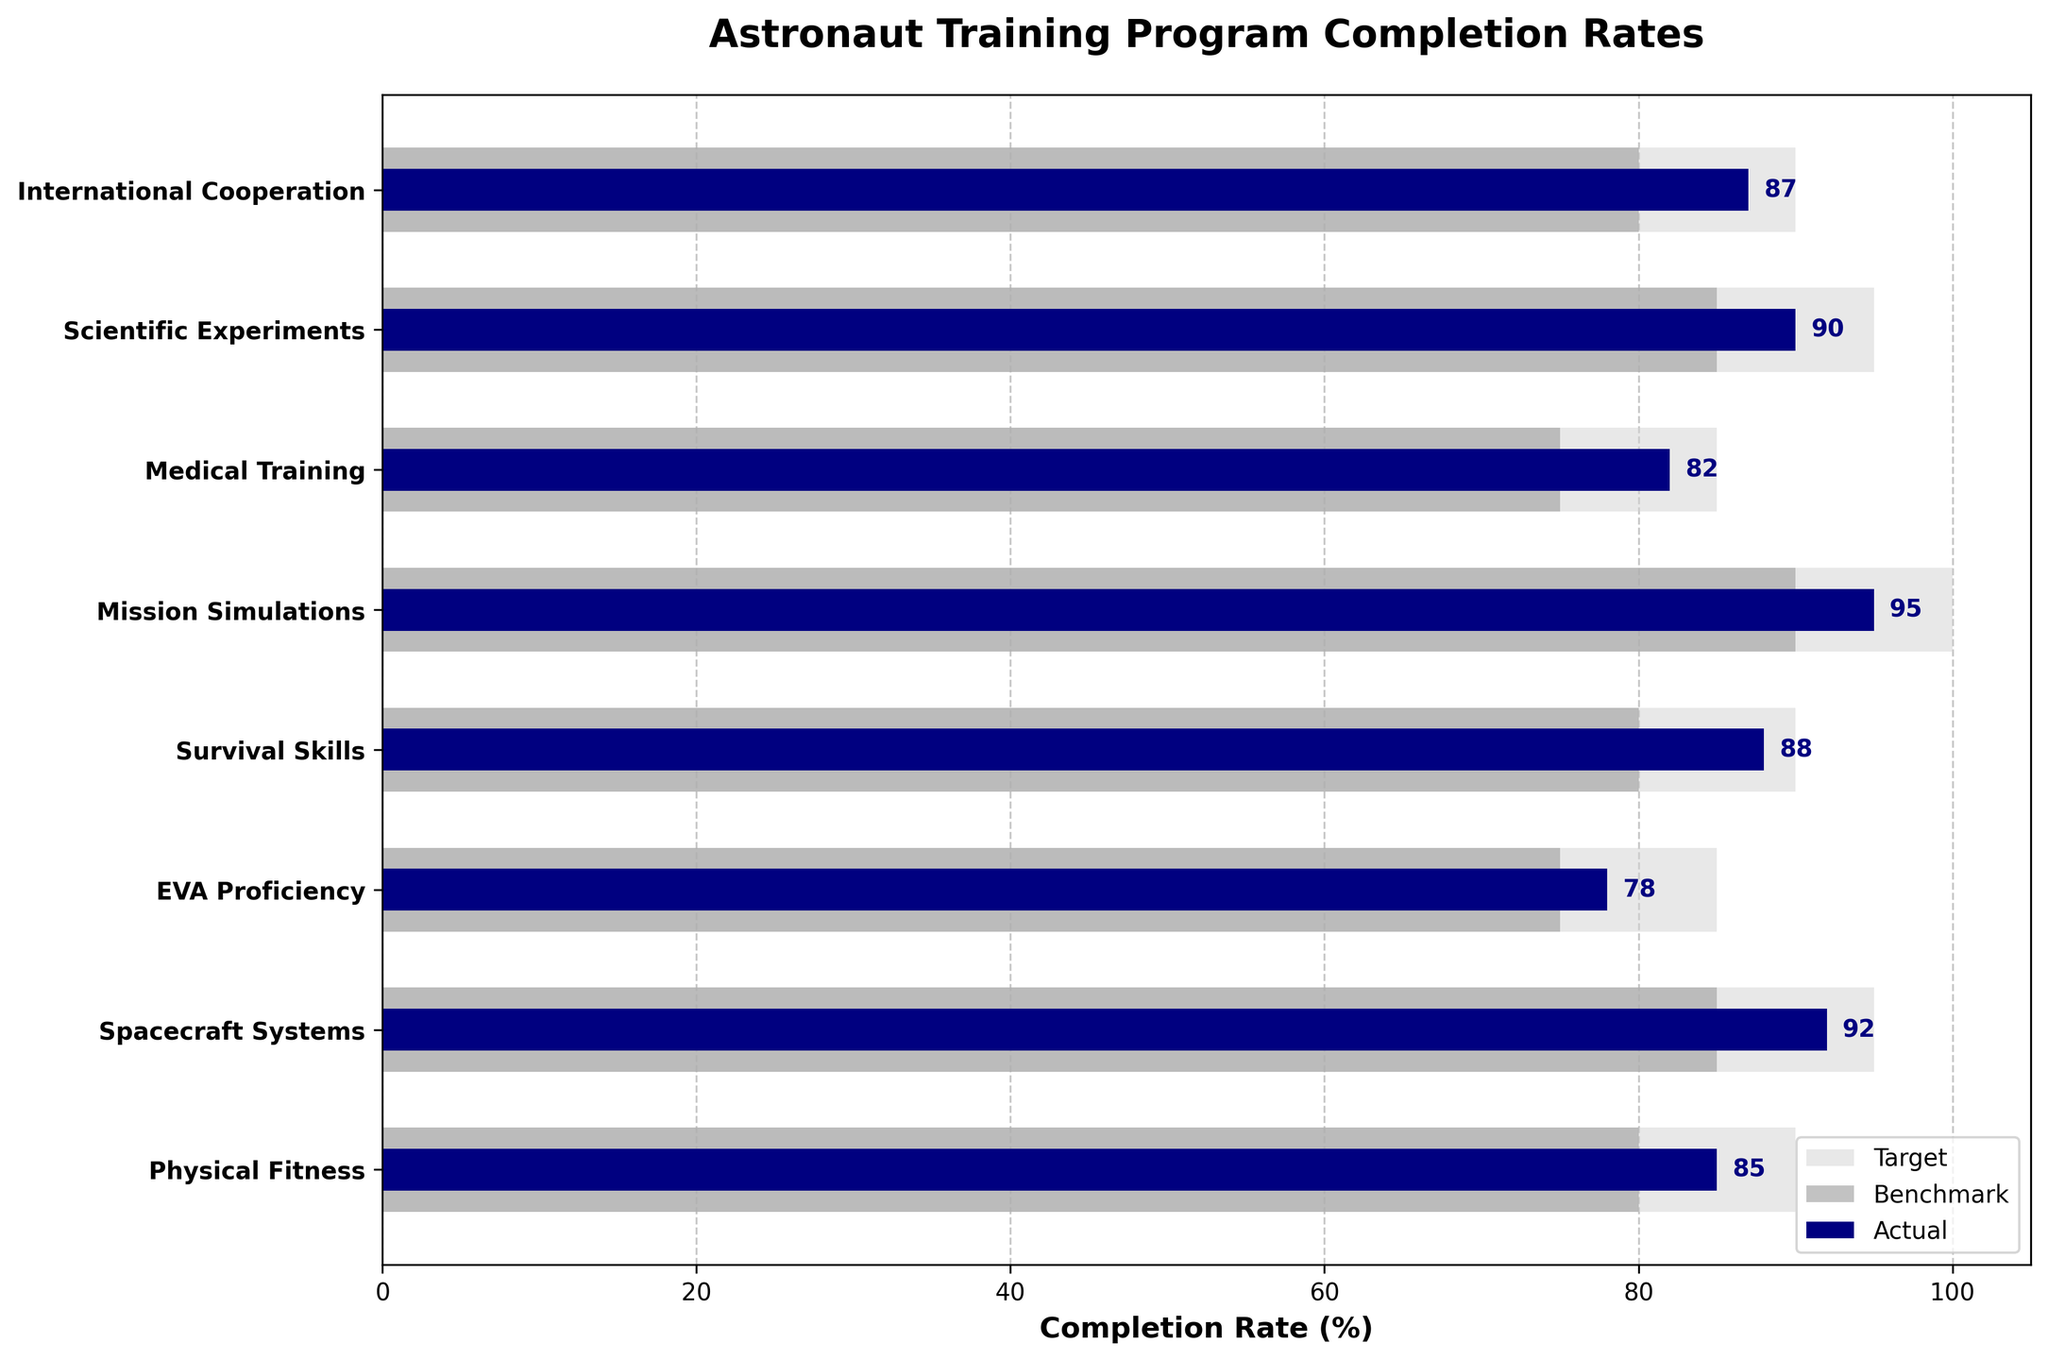what is the title of the chart? The title of the chart is a text element usually located at the top of the figure. The title for this graph is "Astronaut Training Program Completion Rates", as observed at the top of the chart.
Answer: Astronaut Training Program Completion Rates what are the three colors used in the bars and what do they represent? The bullet chart employs three different colors for the bars: light grey for 'Target', dark grey for 'Benchmark', and navy blue for 'Actual'. This is indicated by the color coding in the legend at the bottom right of the figure.
Answer: light grey, dark grey, navy blue which training program has the highest actual completion rate? By examining the navy bars, which represent the actual completion rates, it's clear that the 'Mission Simulations' program has the highest actual completion rate of 95%.
Answer: Mission Simulations how many programs met or exceeded their benchmark completion rates? To determine this, compare the navy bars (Actual) against the dark grey bars (Benchmark) for each program. The programs 'Physical Fitness', 'Spacecraft Systems', 'EVA Proficiency', 'Survival Skills', 'Mission Simulations', 'Medical Training', 'Scientific Experiments', and 'International Cooperation' all meet or exceed their benchmarks. Therefore, 8 programs met or exceeded their benchmarks.
Answer: 8 which program’s actual completion rate is closest to its target completion rate? To find this, we need to assess the difference between the actual (navy blue) and target (light grey) bars for each program. The 'Survival Skills' program, with an actual rate of 88% and a target of 90%, has the smallest gap of 2%.
Answer: Survival Skills what’s the average benchmark completion rate for all programs? The benchmark rates given are 80, 85, 75, 80, 90, 75, 85, and 80. Summing these up equals 650. There are 8 programs, so dividing this sum by 8 yields an average benchmark completion rate of 81.25%.
Answer: 81.25 which program has the largest gap between the actual and target completion rates? By calculating the difference between the actual and target rates for all programs, we'll notice that 'Mission Simulations' has the most significant gap (target of 100 and actual of 95) with a difference of 5%.
Answer: Mission Simulations how many programs have an actual completion rate of 85% or more? By examining the actual completion rates (navy blue), the programs 'Physical Fitness', 'Spacecraft Systems', 'Survival Skills', 'Mission Simulations', 'Scientific Experiments', and 'International Cooperation' all have completion rates of 85% or more. Thus, 6 programs meet this criterion.
Answer: 6 